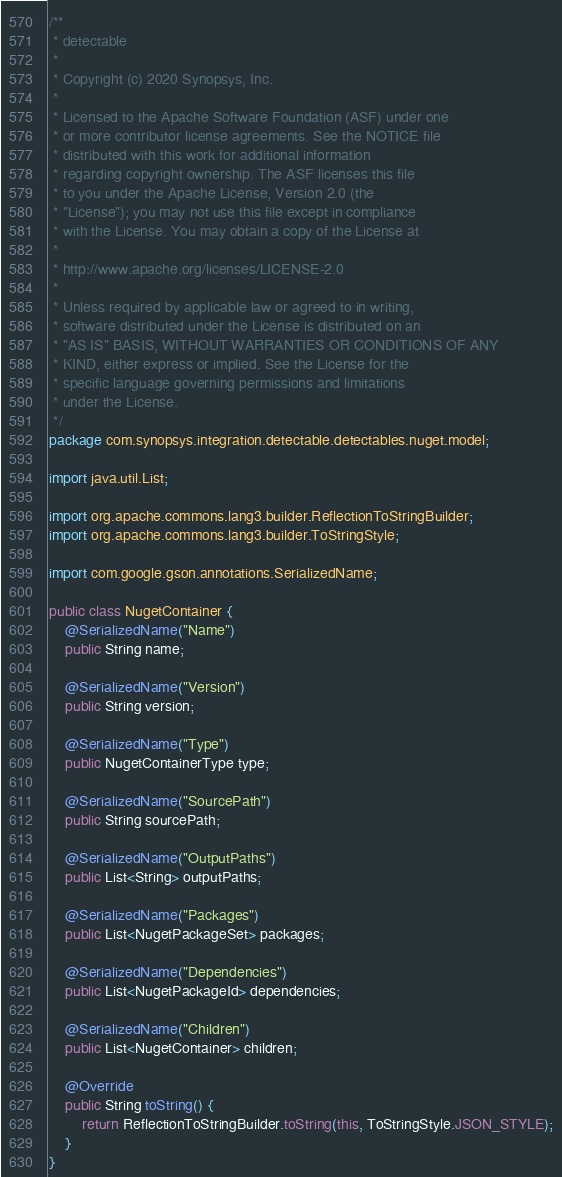Convert code to text. <code><loc_0><loc_0><loc_500><loc_500><_Java_>/**
 * detectable
 *
 * Copyright (c) 2020 Synopsys, Inc.
 *
 * Licensed to the Apache Software Foundation (ASF) under one
 * or more contributor license agreements. See the NOTICE file
 * distributed with this work for additional information
 * regarding copyright ownership. The ASF licenses this file
 * to you under the Apache License, Version 2.0 (the
 * "License"); you may not use this file except in compliance
 * with the License. You may obtain a copy of the License at
 *
 * http://www.apache.org/licenses/LICENSE-2.0
 *
 * Unless required by applicable law or agreed to in writing,
 * software distributed under the License is distributed on an
 * "AS IS" BASIS, WITHOUT WARRANTIES OR CONDITIONS OF ANY
 * KIND, either express or implied. See the License for the
 * specific language governing permissions and limitations
 * under the License.
 */
package com.synopsys.integration.detectable.detectables.nuget.model;

import java.util.List;

import org.apache.commons.lang3.builder.ReflectionToStringBuilder;
import org.apache.commons.lang3.builder.ToStringStyle;

import com.google.gson.annotations.SerializedName;

public class NugetContainer {
    @SerializedName("Name")
    public String name;

    @SerializedName("Version")
    public String version;

    @SerializedName("Type")
    public NugetContainerType type;

    @SerializedName("SourcePath")
    public String sourcePath;

    @SerializedName("OutputPaths")
    public List<String> outputPaths;

    @SerializedName("Packages")
    public List<NugetPackageSet> packages;

    @SerializedName("Dependencies")
    public List<NugetPackageId> dependencies;

    @SerializedName("Children")
    public List<NugetContainer> children;

    @Override
    public String toString() {
        return ReflectionToStringBuilder.toString(this, ToStringStyle.JSON_STYLE);
    }
}
</code> 